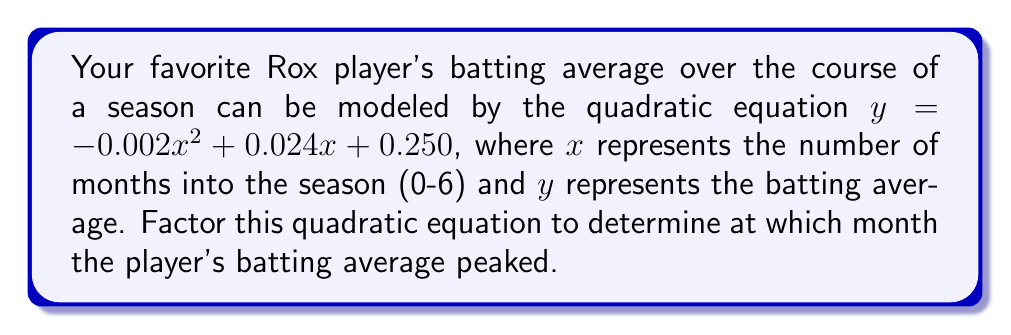Can you solve this math problem? To factor this quadratic equation, we'll follow these steps:

1) First, let's identify the coefficients:
   $a = -0.002$, $b = 0.024$, and $c = 0.250$

2) We'll use the quadratic formula to find the roots:
   $x = \frac{-b \pm \sqrt{b^2 - 4ac}}{2a}$

3) Let's calculate the discriminant:
   $b^2 - 4ac = (0.024)^2 - 4(-0.002)(0.250) = 0.000576 + 0.002 = 0.002576$

4) Now we can solve for x:
   $x = \frac{-0.024 \pm \sqrt{0.002576}}{2(-0.002)}$
   $x = \frac{-0.024 \pm 0.0508}{-0.004}$

5) This gives us two solutions:
   $x_1 = \frac{-0.024 + 0.0508}{-0.004} = 6$
   $x_2 = \frac{-0.024 - 0.0508}{-0.004} = 18.7$

6) The factored form of the quadratic is:
   $y = -0.002(x - 6)(x - 18.7)$

7) The axis of symmetry of a parabola is halfway between its roots:
   $x = \frac{6 + 18.7}{2} = 12.35$

8) Since we're only considering 0-6 months, the peak occurs at 6 months.
Answer: The factored form is $y = -0.002(x - 6)(x - 18.7)$. The player's batting average peaked at 6 months into the season. 